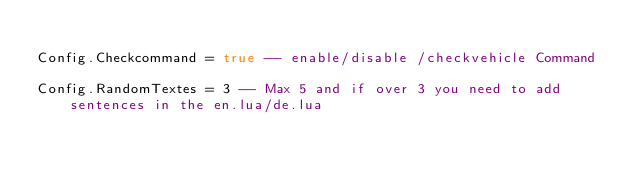Convert code to text. <code><loc_0><loc_0><loc_500><loc_500><_Lua_>
Config.Checkcommand = true -- enable/disable /checkvehicle Command

Config.RandomTextes = 3 -- Max 5 and if over 3 you need to add sentences in the en.lua/de.lua</code> 